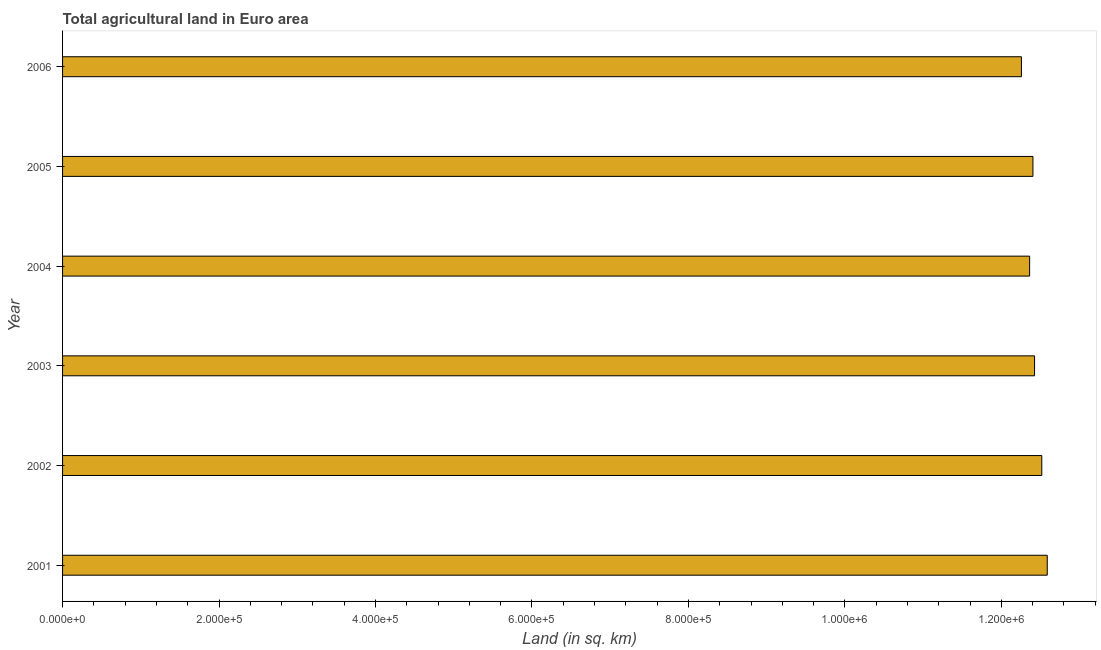What is the title of the graph?
Offer a terse response. Total agricultural land in Euro area. What is the label or title of the X-axis?
Offer a very short reply. Land (in sq. km). What is the label or title of the Y-axis?
Provide a short and direct response. Year. What is the agricultural land in 2001?
Offer a terse response. 1.26e+06. Across all years, what is the maximum agricultural land?
Keep it short and to the point. 1.26e+06. Across all years, what is the minimum agricultural land?
Provide a succinct answer. 1.23e+06. In which year was the agricultural land minimum?
Provide a short and direct response. 2006. What is the sum of the agricultural land?
Keep it short and to the point. 7.45e+06. What is the difference between the agricultural land in 2002 and 2004?
Provide a succinct answer. 1.55e+04. What is the average agricultural land per year?
Your answer should be compact. 1.24e+06. What is the median agricultural land?
Your response must be concise. 1.24e+06. In how many years, is the agricultural land greater than 440000 sq. km?
Your answer should be compact. 6. Do a majority of the years between 2001 and 2004 (inclusive) have agricultural land greater than 1240000 sq. km?
Offer a very short reply. Yes. What is the ratio of the agricultural land in 2003 to that in 2005?
Your answer should be very brief. 1. Is the agricultural land in 2003 less than that in 2005?
Make the answer very short. No. What is the difference between the highest and the second highest agricultural land?
Provide a succinct answer. 7001. Is the sum of the agricultural land in 2001 and 2005 greater than the maximum agricultural land across all years?
Provide a succinct answer. Yes. What is the difference between the highest and the lowest agricultural land?
Make the answer very short. 3.30e+04. In how many years, is the agricultural land greater than the average agricultural land taken over all years?
Provide a succinct answer. 2. How many bars are there?
Offer a terse response. 6. How many years are there in the graph?
Give a very brief answer. 6. What is the difference between two consecutive major ticks on the X-axis?
Keep it short and to the point. 2.00e+05. Are the values on the major ticks of X-axis written in scientific E-notation?
Your response must be concise. Yes. What is the Land (in sq. km) of 2001?
Offer a terse response. 1.26e+06. What is the Land (in sq. km) of 2002?
Your response must be concise. 1.25e+06. What is the Land (in sq. km) in 2003?
Offer a terse response. 1.24e+06. What is the Land (in sq. km) in 2004?
Your answer should be very brief. 1.24e+06. What is the Land (in sq. km) of 2005?
Your response must be concise. 1.24e+06. What is the Land (in sq. km) of 2006?
Provide a succinct answer. 1.23e+06. What is the difference between the Land (in sq. km) in 2001 and 2002?
Offer a terse response. 7001. What is the difference between the Land (in sq. km) in 2001 and 2003?
Provide a short and direct response. 1.62e+04. What is the difference between the Land (in sq. km) in 2001 and 2004?
Offer a terse response. 2.25e+04. What is the difference between the Land (in sq. km) in 2001 and 2005?
Provide a short and direct response. 1.83e+04. What is the difference between the Land (in sq. km) in 2001 and 2006?
Provide a succinct answer. 3.30e+04. What is the difference between the Land (in sq. km) in 2002 and 2003?
Ensure brevity in your answer.  9229.7. What is the difference between the Land (in sq. km) in 2002 and 2004?
Your response must be concise. 1.55e+04. What is the difference between the Land (in sq. km) in 2002 and 2005?
Keep it short and to the point. 1.13e+04. What is the difference between the Land (in sq. km) in 2002 and 2006?
Your answer should be compact. 2.60e+04. What is the difference between the Land (in sq. km) in 2003 and 2004?
Your answer should be compact. 6314.3. What is the difference between the Land (in sq. km) in 2003 and 2005?
Ensure brevity in your answer.  2067.8. What is the difference between the Land (in sq. km) in 2003 and 2006?
Keep it short and to the point. 1.68e+04. What is the difference between the Land (in sq. km) in 2004 and 2005?
Make the answer very short. -4246.5. What is the difference between the Land (in sq. km) in 2004 and 2006?
Ensure brevity in your answer.  1.05e+04. What is the difference between the Land (in sq. km) in 2005 and 2006?
Offer a terse response. 1.47e+04. What is the ratio of the Land (in sq. km) in 2001 to that in 2006?
Your answer should be very brief. 1.03. What is the ratio of the Land (in sq. km) in 2002 to that in 2004?
Your answer should be very brief. 1.01. What is the ratio of the Land (in sq. km) in 2002 to that in 2005?
Offer a terse response. 1.01. What is the ratio of the Land (in sq. km) in 2003 to that in 2004?
Provide a short and direct response. 1. What is the ratio of the Land (in sq. km) in 2005 to that in 2006?
Ensure brevity in your answer.  1.01. 